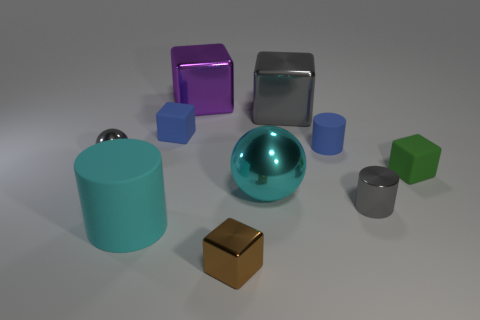Do the tiny brown shiny thing and the cyan matte object have the same shape?
Your response must be concise. No. The gray cylinder has what size?
Provide a short and direct response. Small. What number of cyan balls are the same size as the cyan rubber cylinder?
Offer a terse response. 1. Is the size of the matte cylinder left of the brown cube the same as the metal cube to the right of the large cyan metal ball?
Make the answer very short. Yes. There is a blue object left of the brown metallic cube; what shape is it?
Your answer should be very brief. Cube. What is the material of the tiny cube on the left side of the small cube that is in front of the green object?
Your response must be concise. Rubber. Are there any cubes of the same color as the tiny rubber cylinder?
Your answer should be very brief. Yes. There is a gray sphere; is it the same size as the cyan cylinder that is to the left of the tiny rubber cylinder?
Make the answer very short. No. There is a blue matte object on the right side of the purple shiny block that is behind the small green rubber block; what number of blue matte objects are left of it?
Make the answer very short. 1. There is a tiny green block; how many tiny blocks are behind it?
Keep it short and to the point. 1. 